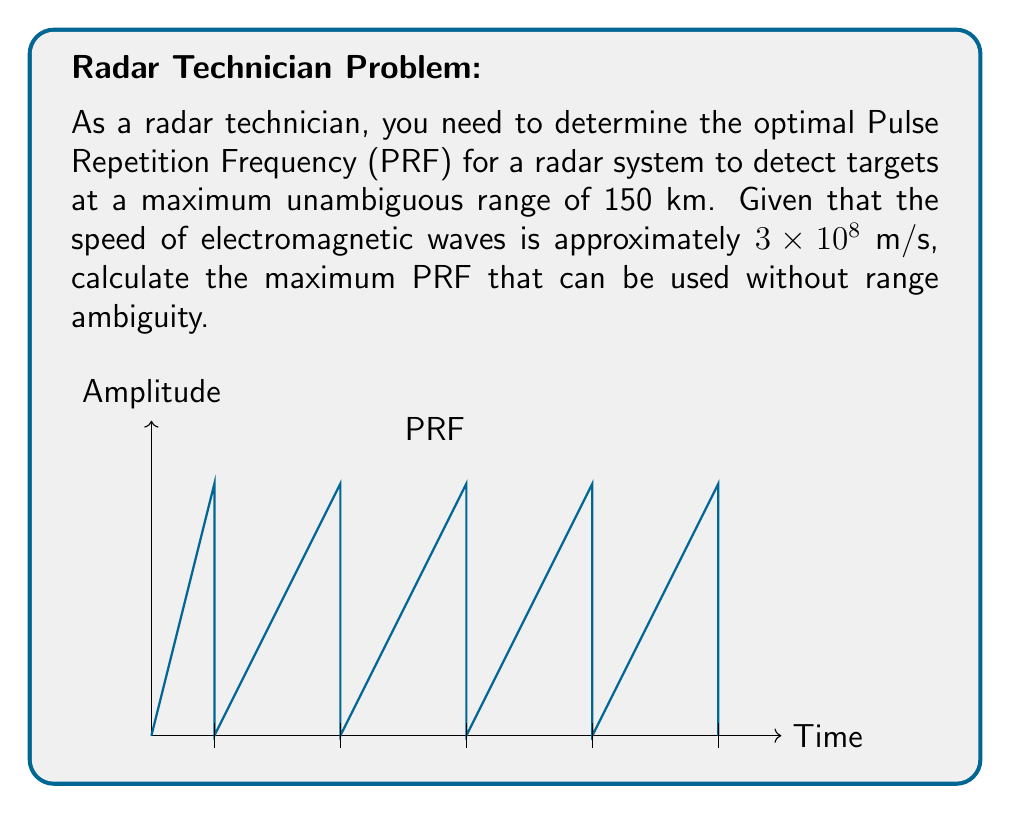Solve this math problem. To solve this problem, we need to follow these steps:

1) First, recall that the Pulse Repetition Frequency (PRF) is the number of pulses transmitted per second. The time between two consecutive pulses is called the Pulse Repetition Time (PRT).

2) The relationship between PRF and PRT is:

   $$PRF = \frac{1}{PRT}$$

3) To avoid range ambiguity, the radar must receive the echo from the maximum range before transmitting the next pulse. Therefore, the PRT must be at least equal to the round-trip time for a signal to travel to the maximum range and back.

4) The round-trip time (t) for a signal to travel to the maximum range (R) and back is:

   $$t = \frac{2R}{c}$$

   where c is the speed of electromagnetic waves.

5) Substituting the given values:

   $$t = \frac{2 \times 150,000 \text{ m}}{3 \times 10^8 \text{ m/s}} = 0.001 \text{ s} = 1 \text{ ms}$$

6) This means the PRT must be at least 1 ms to avoid range ambiguity.

7) Now we can calculate the maximum PRF:

   $$PRF_{max} = \frac{1}{PRT_{min}} = \frac{1}{0.001 \text{ s}} = 1000 \text{ Hz}$$

Therefore, the maximum PRF that can be used without range ambiguity is 1000 Hz.
Answer: 1000 Hz 